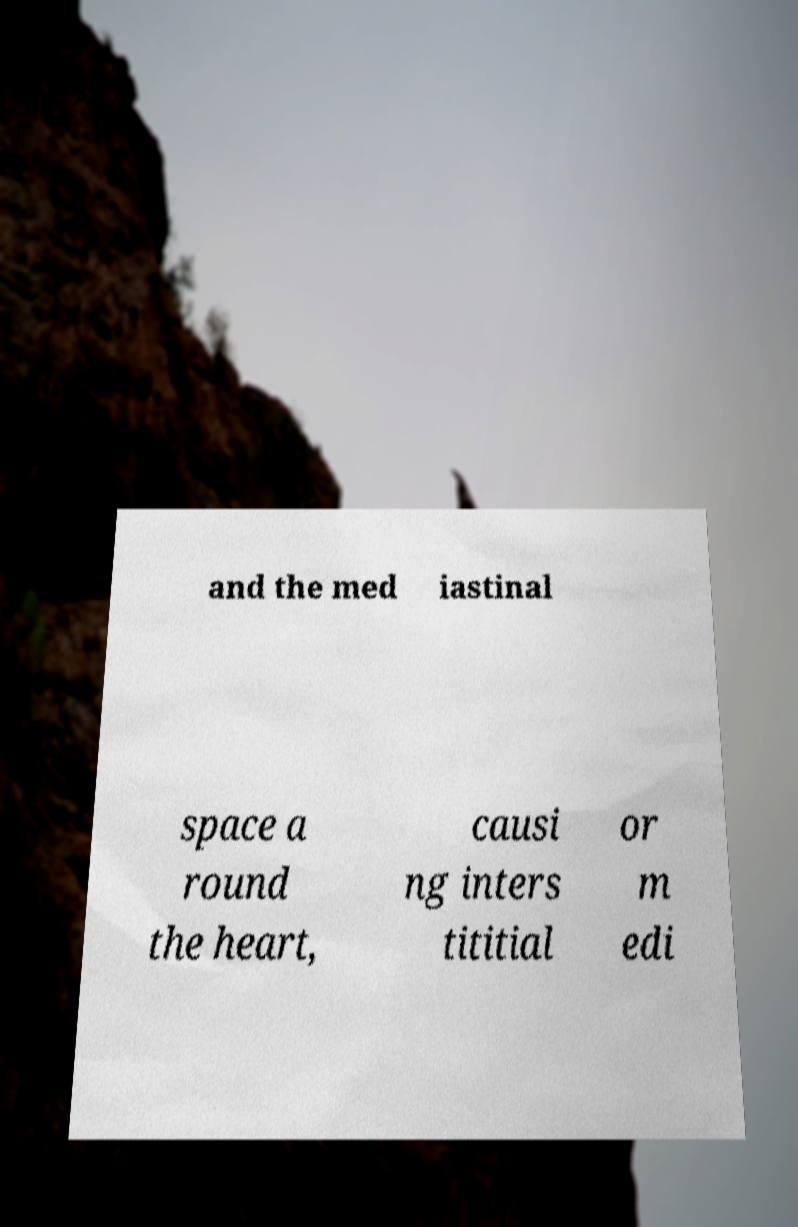Can you accurately transcribe the text from the provided image for me? and the med iastinal space a round the heart, causi ng inters tititial or m edi 